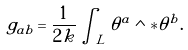Convert formula to latex. <formula><loc_0><loc_0><loc_500><loc_500>g _ { a b } = \frac { 1 } { 2 k } \int _ { L } \theta ^ { a } \wedge * \theta ^ { b } .</formula> 